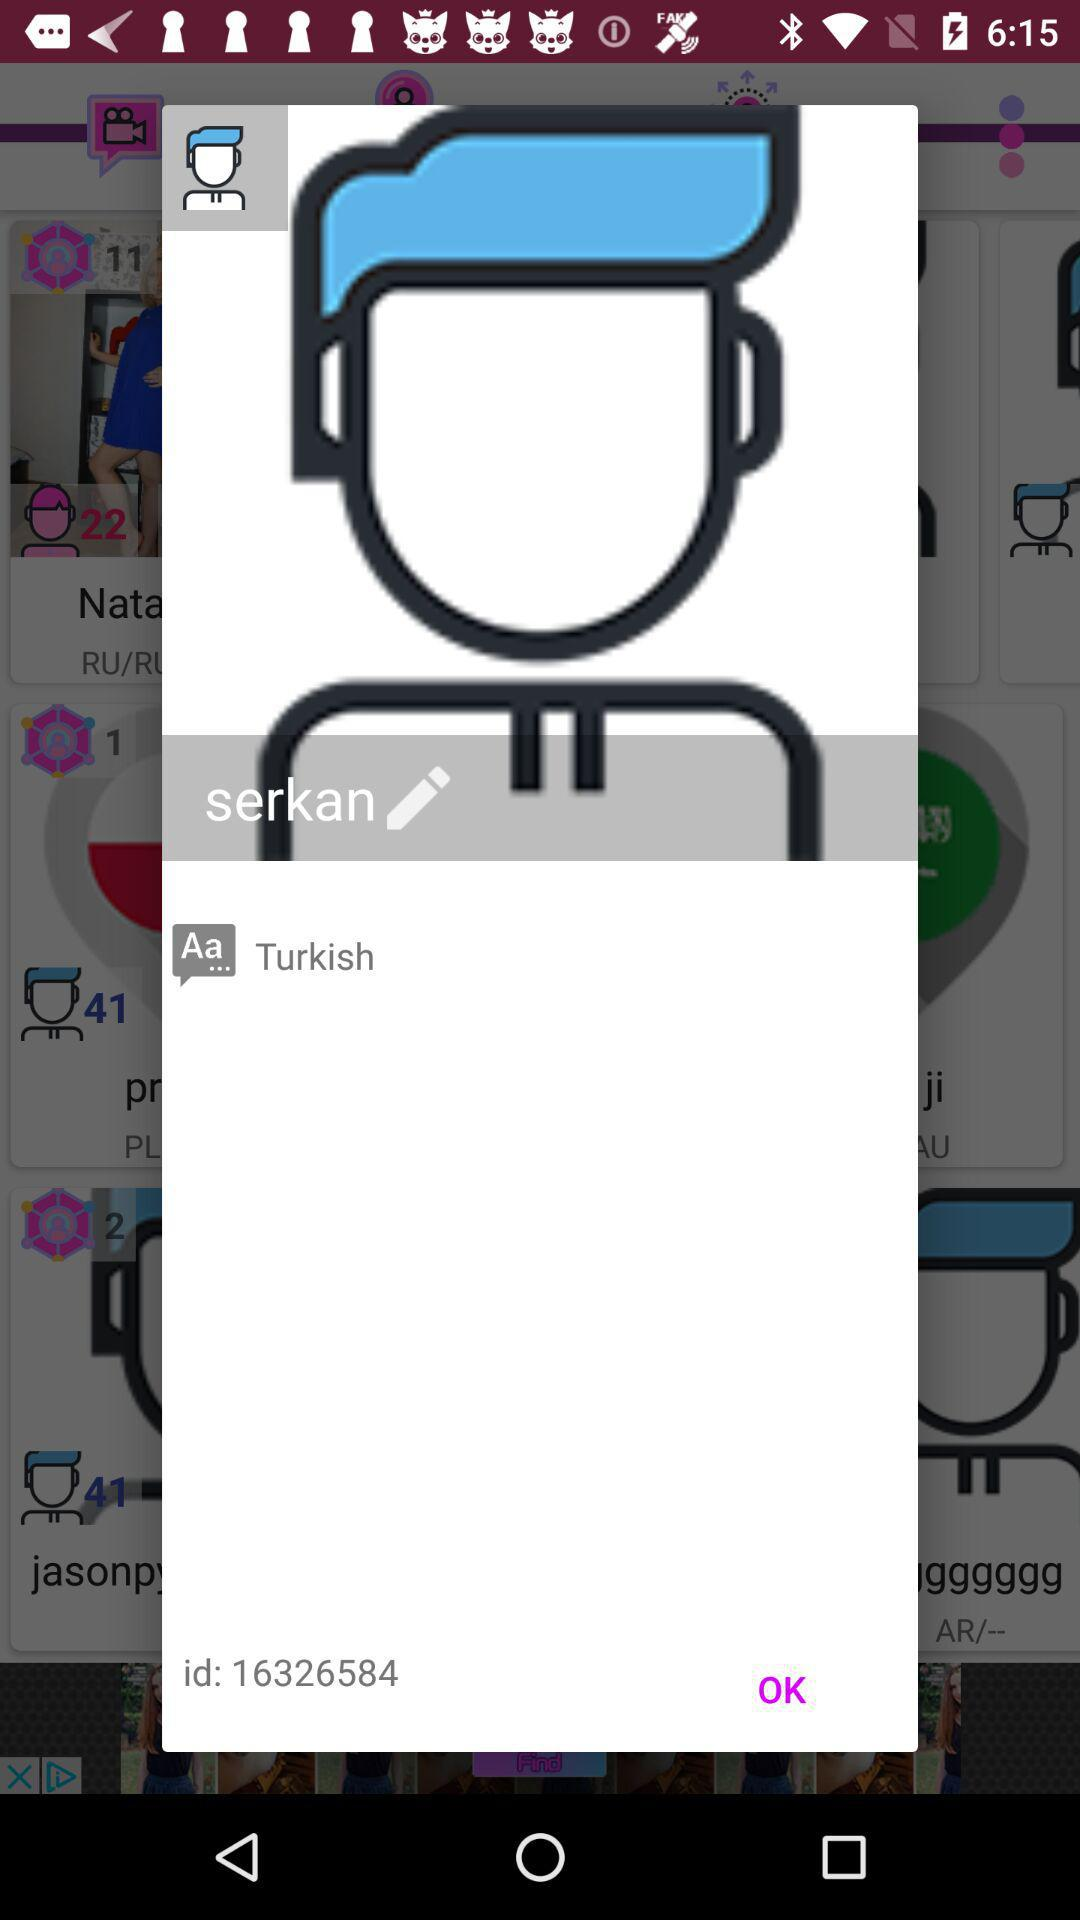What is the chosen language to input? The chosen language is Turkish. 